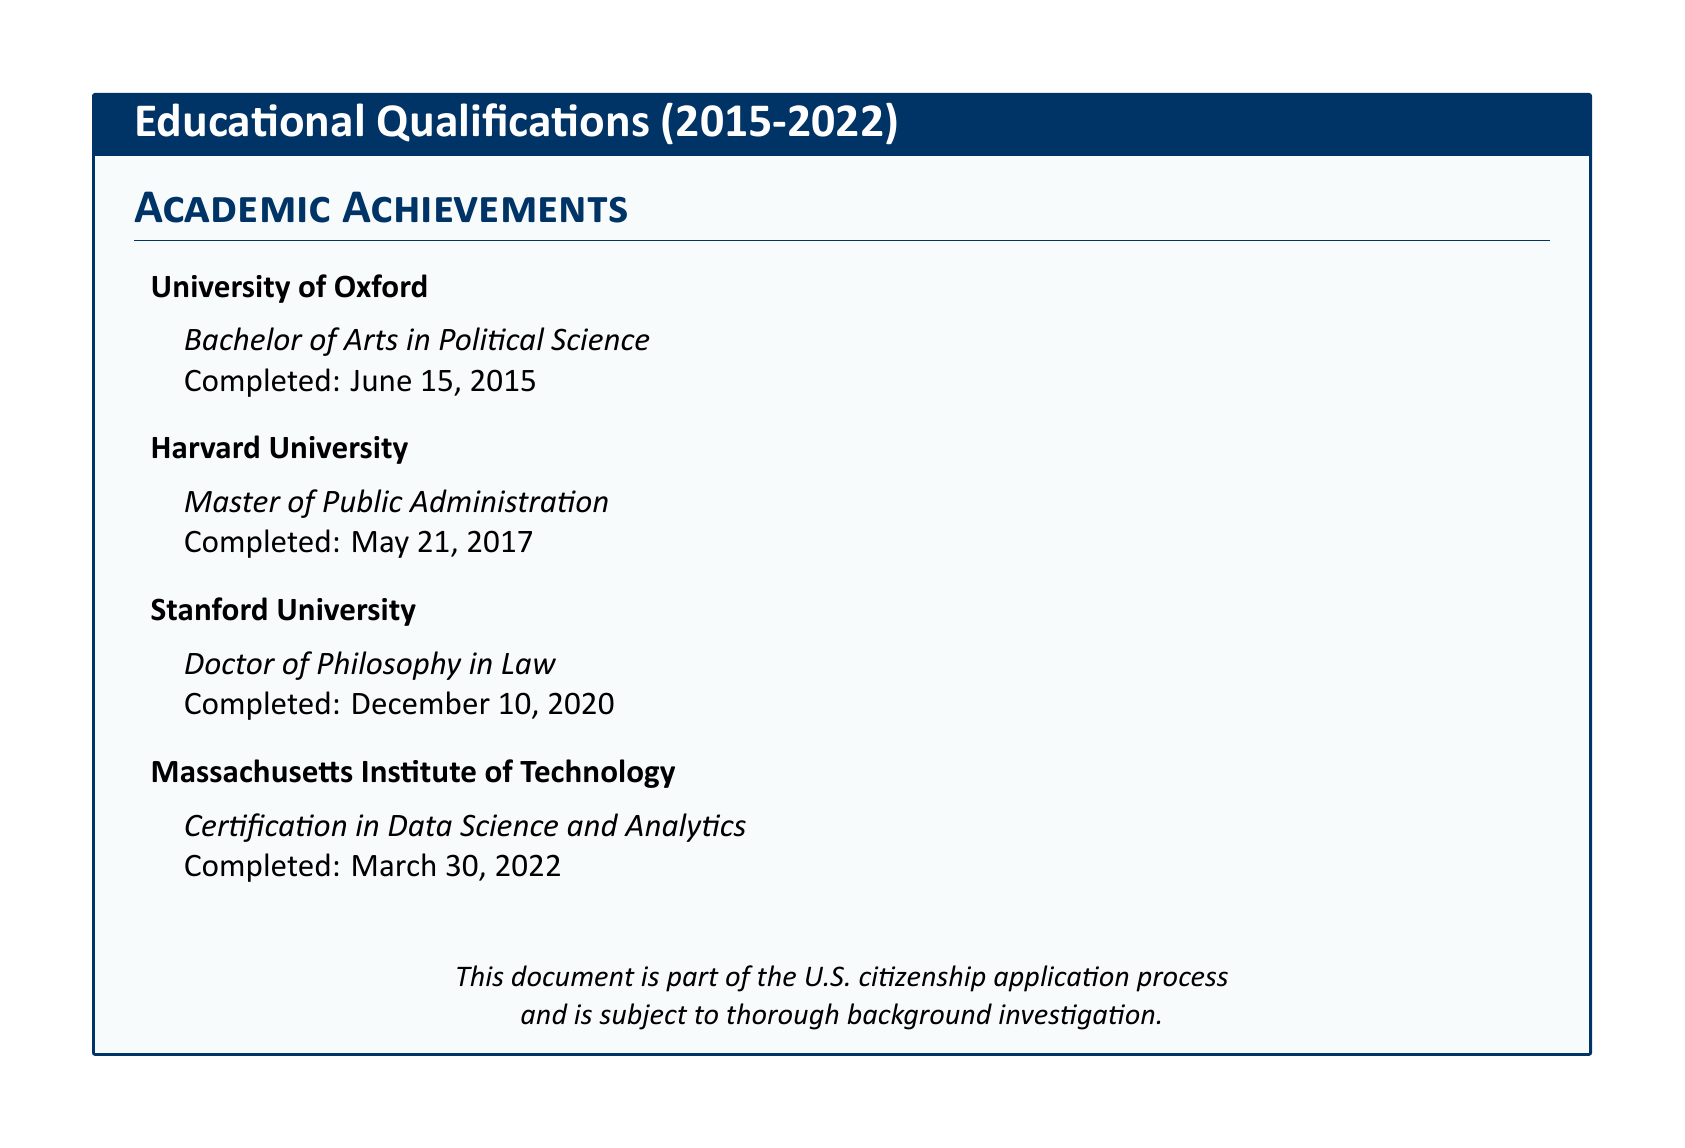What degree was earned at the University of Oxford? The document states that a Bachelor of Arts in Political Science was earned at the University of Oxford.
Answer: Bachelor of Arts in Political Science When was the Master of Public Administration completed? The completion date for the Master of Public Administration is noted as May 21, 2017.
Answer: May 21, 2017 Which institution awarded the Doctor of Philosophy in Law? The document indicates that the Doctor of Philosophy in Law was awarded by Stanford University.
Answer: Stanford University What certification was obtained in 2022? The document specifies that a Certification in Data Science and Analytics was obtained in March 2022.
Answer: Certification in Data Science and Analytics How many educational qualifications are listed from 2015 to 2022? There are four educational qualifications listed in total from 2015 to 2022.
Answer: Four Which degree was obtained from Harvard University? The document indicates that a Master of Public Administration was earned from Harvard University.
Answer: Master of Public Administration Which institution's certification was completed last? The last completed qualification listed is the Certification in Data Science and Analytics from the Massachusetts Institute of Technology.
Answer: Massachusetts Institute of Technology What year did the educational qualifications begin? The first qualification in the document began in 2015.
Answer: 2015 What type of document is this? This document is identified as part of the U.S. citizenship application process.
Answer: U.S. citizenship application process 